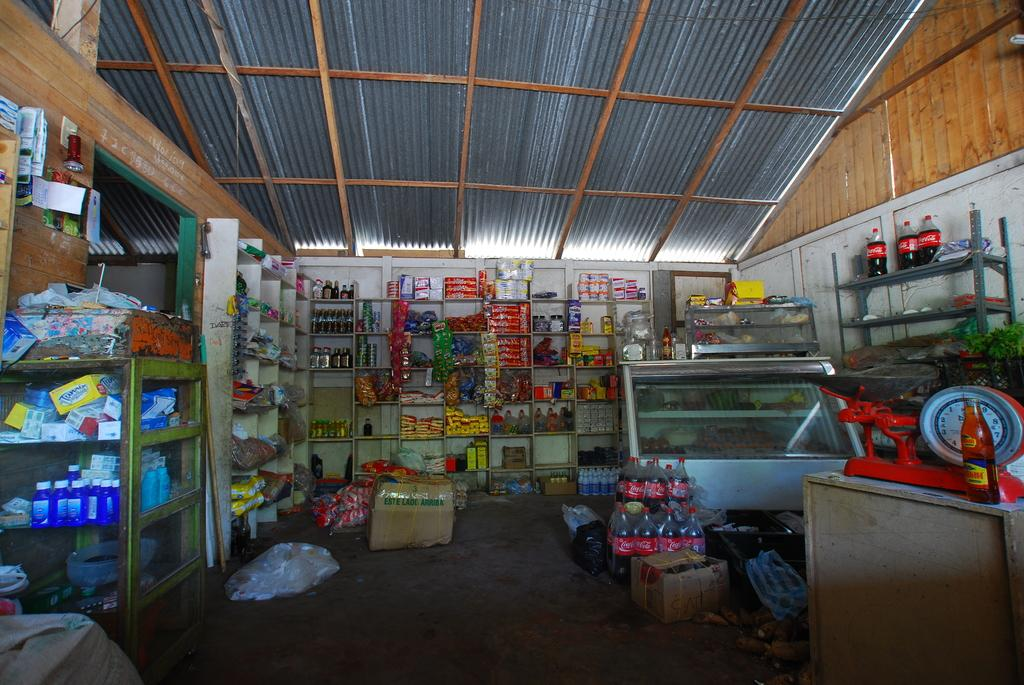Provide a one-sentence caption for the provided image. A storage room with many shelves are holding bottles of Coca Cola among other things. 